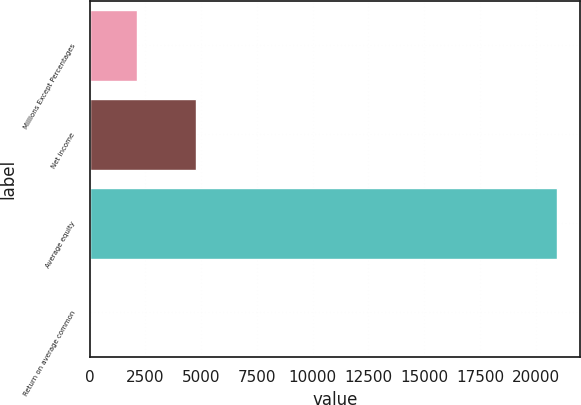Convert chart to OTSL. <chart><loc_0><loc_0><loc_500><loc_500><bar_chart><fcel>Millions Except Percentages<fcel>Net income<fcel>Average equity<fcel>Return on average common<nl><fcel>2115.12<fcel>4772<fcel>20946<fcel>22.8<nl></chart> 